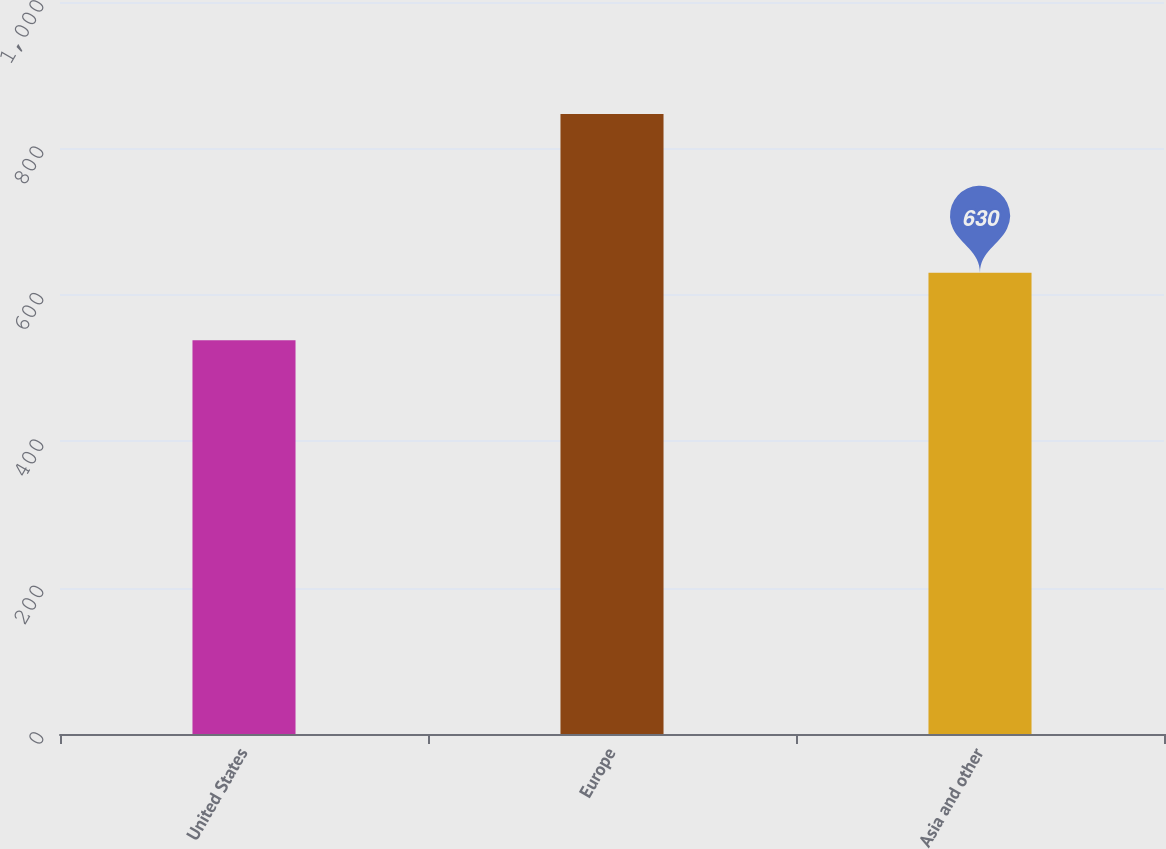Convert chart to OTSL. <chart><loc_0><loc_0><loc_500><loc_500><bar_chart><fcel>United States<fcel>Europe<fcel>Asia and other<nl><fcel>538<fcel>847<fcel>630<nl></chart> 